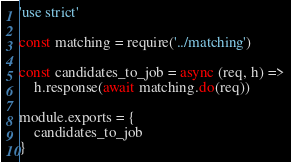Convert code to text. <code><loc_0><loc_0><loc_500><loc_500><_JavaScript_>'use strict'

const matching = require('../matching')

const candidates_to_job = async (req, h) =>
	h.response(await matching.do(req))

module.exports = {
	candidates_to_job
}
</code> 